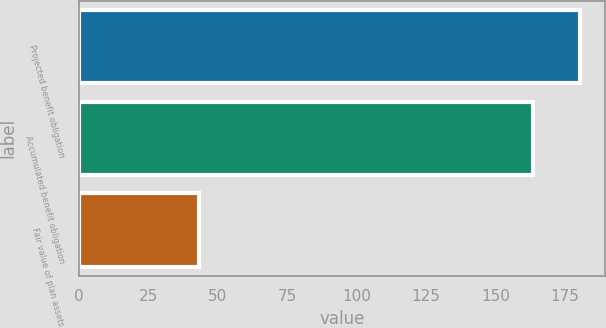<chart> <loc_0><loc_0><loc_500><loc_500><bar_chart><fcel>Projected benefit obligation<fcel>Accumulated benefit obligation<fcel>Fair value of plan assets<nl><fcel>180.6<fcel>163.6<fcel>43.2<nl></chart> 